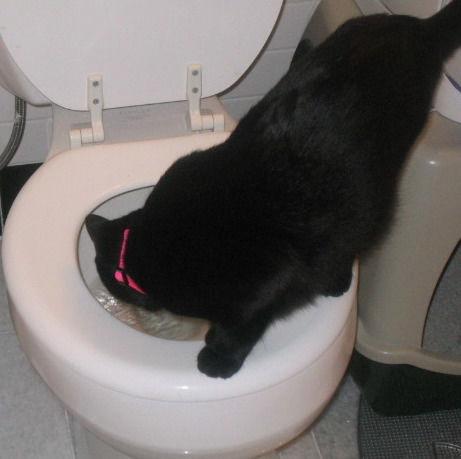What animal is thirsty?
Short answer required. Cat. What is the color of the toilet?
Write a very short answer. White. Does this cat have white paws?
Be succinct. No. Why would most people find this image distasteful?
Concise answer only. Cat is drinking toilet water. 